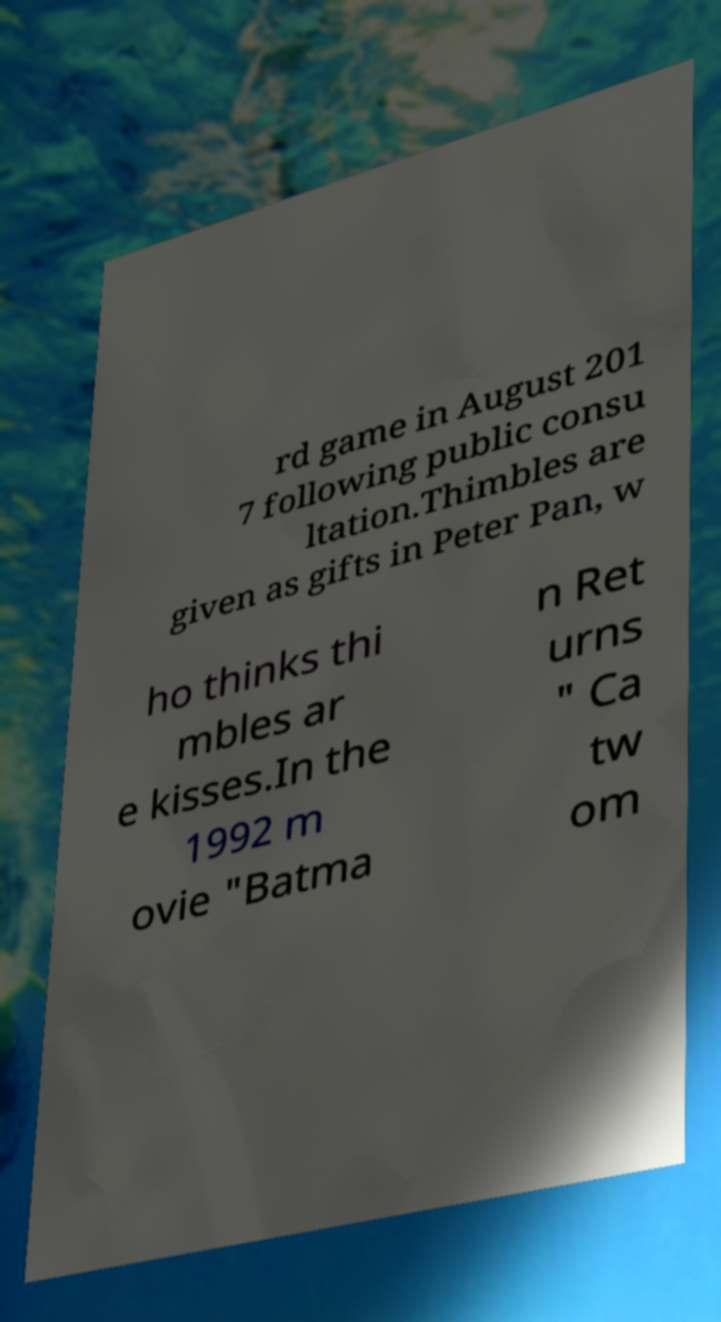I need the written content from this picture converted into text. Can you do that? rd game in August 201 7 following public consu ltation.Thimbles are given as gifts in Peter Pan, w ho thinks thi mbles ar e kisses.In the 1992 m ovie "Batma n Ret urns " Ca tw om 